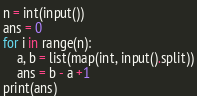<code> <loc_0><loc_0><loc_500><loc_500><_Python_>n = int(input())
ans = 0
for i in range(n):
    a, b = list(map(int, input().split))
    ans = b - a +1
print(ans)</code> 